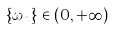<formula> <loc_0><loc_0><loc_500><loc_500>\{ \omega _ { n } \} \in ( 0 , + \infty ) ^ { \mathbb { Z } }</formula> 